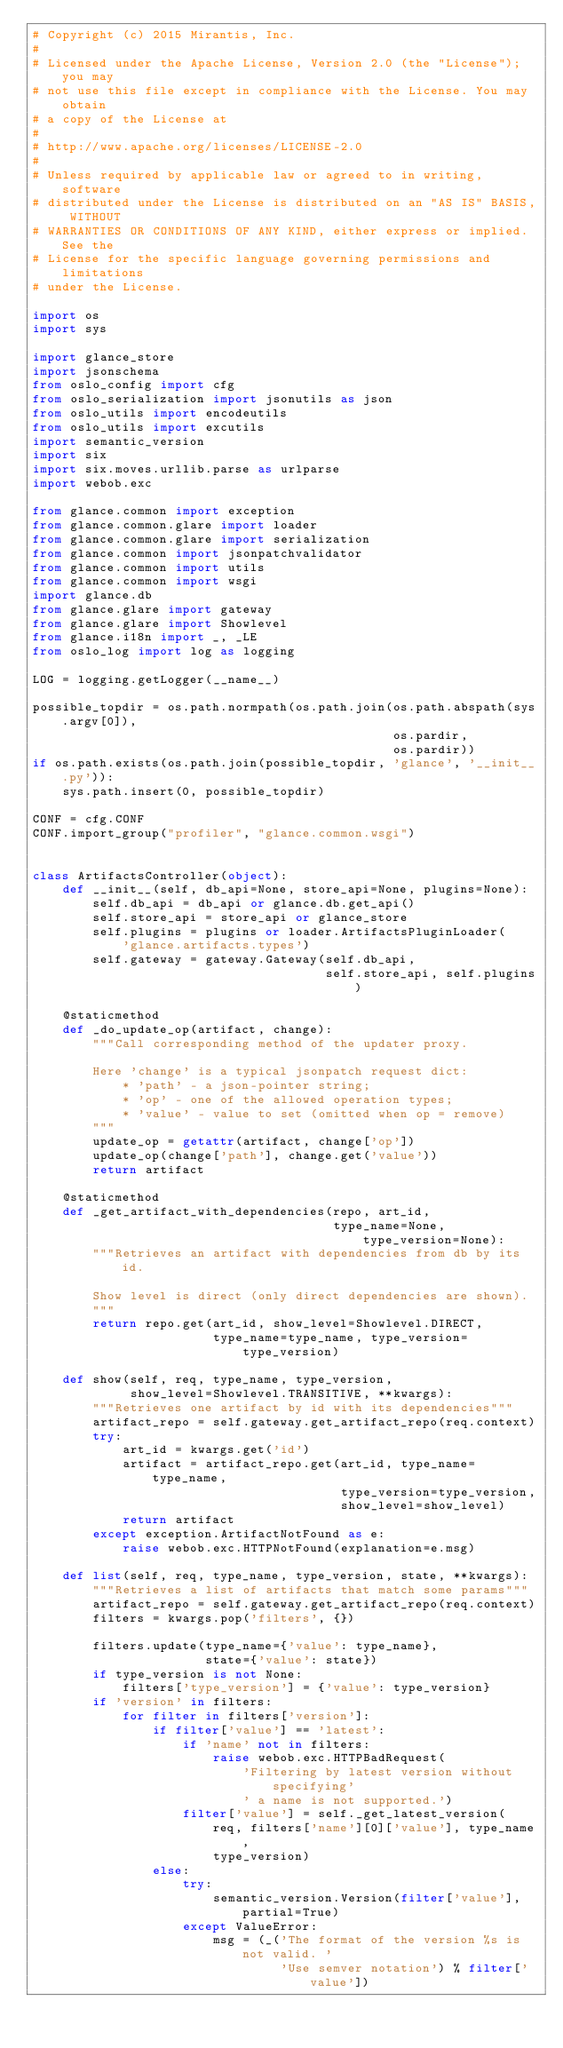Convert code to text. <code><loc_0><loc_0><loc_500><loc_500><_Python_># Copyright (c) 2015 Mirantis, Inc.
#
# Licensed under the Apache License, Version 2.0 (the "License"); you may
# not use this file except in compliance with the License. You may obtain
# a copy of the License at
#
# http://www.apache.org/licenses/LICENSE-2.0
#
# Unless required by applicable law or agreed to in writing, software
# distributed under the License is distributed on an "AS IS" BASIS, WITHOUT
# WARRANTIES OR CONDITIONS OF ANY KIND, either express or implied. See the
# License for the specific language governing permissions and limitations
# under the License.

import os
import sys

import glance_store
import jsonschema
from oslo_config import cfg
from oslo_serialization import jsonutils as json
from oslo_utils import encodeutils
from oslo_utils import excutils
import semantic_version
import six
import six.moves.urllib.parse as urlparse
import webob.exc

from glance.common import exception
from glance.common.glare import loader
from glance.common.glare import serialization
from glance.common import jsonpatchvalidator
from glance.common import utils
from glance.common import wsgi
import glance.db
from glance.glare import gateway
from glance.glare import Showlevel
from glance.i18n import _, _LE
from oslo_log import log as logging

LOG = logging.getLogger(__name__)

possible_topdir = os.path.normpath(os.path.join(os.path.abspath(sys.argv[0]),
                                                os.pardir,
                                                os.pardir))
if os.path.exists(os.path.join(possible_topdir, 'glance', '__init__.py')):
    sys.path.insert(0, possible_topdir)

CONF = cfg.CONF
CONF.import_group("profiler", "glance.common.wsgi")


class ArtifactsController(object):
    def __init__(self, db_api=None, store_api=None, plugins=None):
        self.db_api = db_api or glance.db.get_api()
        self.store_api = store_api or glance_store
        self.plugins = plugins or loader.ArtifactsPluginLoader(
            'glance.artifacts.types')
        self.gateway = gateway.Gateway(self.db_api,
                                       self.store_api, self.plugins)

    @staticmethod
    def _do_update_op(artifact, change):
        """Call corresponding method of the updater proxy.

        Here 'change' is a typical jsonpatch request dict:
            * 'path' - a json-pointer string;
            * 'op' - one of the allowed operation types;
            * 'value' - value to set (omitted when op = remove)
        """
        update_op = getattr(artifact, change['op'])
        update_op(change['path'], change.get('value'))
        return artifact

    @staticmethod
    def _get_artifact_with_dependencies(repo, art_id,
                                        type_name=None, type_version=None):
        """Retrieves an artifact with dependencies from db by its id.

        Show level is direct (only direct dependencies are shown).
        """
        return repo.get(art_id, show_level=Showlevel.DIRECT,
                        type_name=type_name, type_version=type_version)

    def show(self, req, type_name, type_version,
             show_level=Showlevel.TRANSITIVE, **kwargs):
        """Retrieves one artifact by id with its dependencies"""
        artifact_repo = self.gateway.get_artifact_repo(req.context)
        try:
            art_id = kwargs.get('id')
            artifact = artifact_repo.get(art_id, type_name=type_name,
                                         type_version=type_version,
                                         show_level=show_level)
            return artifact
        except exception.ArtifactNotFound as e:
            raise webob.exc.HTTPNotFound(explanation=e.msg)

    def list(self, req, type_name, type_version, state, **kwargs):
        """Retrieves a list of artifacts that match some params"""
        artifact_repo = self.gateway.get_artifact_repo(req.context)
        filters = kwargs.pop('filters', {})

        filters.update(type_name={'value': type_name},
                       state={'value': state})
        if type_version is not None:
            filters['type_version'] = {'value': type_version}
        if 'version' in filters:
            for filter in filters['version']:
                if filter['value'] == 'latest':
                    if 'name' not in filters:
                        raise webob.exc.HTTPBadRequest(
                            'Filtering by latest version without specifying'
                            ' a name is not supported.')
                    filter['value'] = self._get_latest_version(
                        req, filters['name'][0]['value'], type_name,
                        type_version)
                else:
                    try:
                        semantic_version.Version(filter['value'], partial=True)
                    except ValueError:
                        msg = (_('The format of the version %s is not valid. '
                                 'Use semver notation') % filter['value'])</code> 